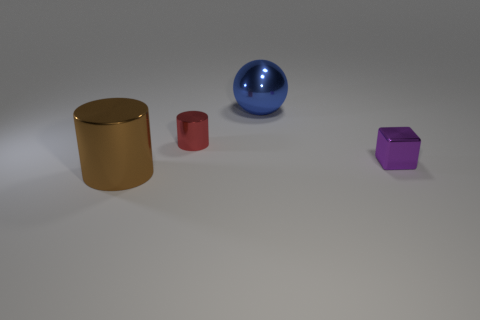Subtract 1 cylinders. How many cylinders are left? 1 Add 2 blue shiny balls. How many objects exist? 6 Subtract all red cylinders. How many cylinders are left? 1 Subtract all cubes. How many objects are left? 3 Subtract 0 gray cylinders. How many objects are left? 4 Subtract all purple blocks. Subtract all gray spheres. How many objects are left? 3 Add 2 brown metal things. How many brown metal things are left? 3 Add 2 big yellow matte things. How many big yellow matte things exist? 2 